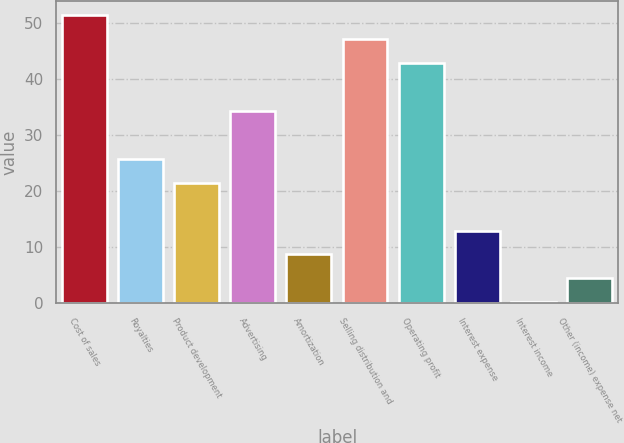Convert chart. <chart><loc_0><loc_0><loc_500><loc_500><bar_chart><fcel>Cost of sales<fcel>Royalties<fcel>Product development<fcel>Advertising<fcel>Amortization<fcel>Selling distribution and<fcel>Operating profit<fcel>Interest expense<fcel>Interest income<fcel>Other (income) expense net<nl><fcel>51.34<fcel>25.72<fcel>21.45<fcel>34.26<fcel>8.64<fcel>47.07<fcel>42.8<fcel>12.91<fcel>0.1<fcel>4.37<nl></chart> 